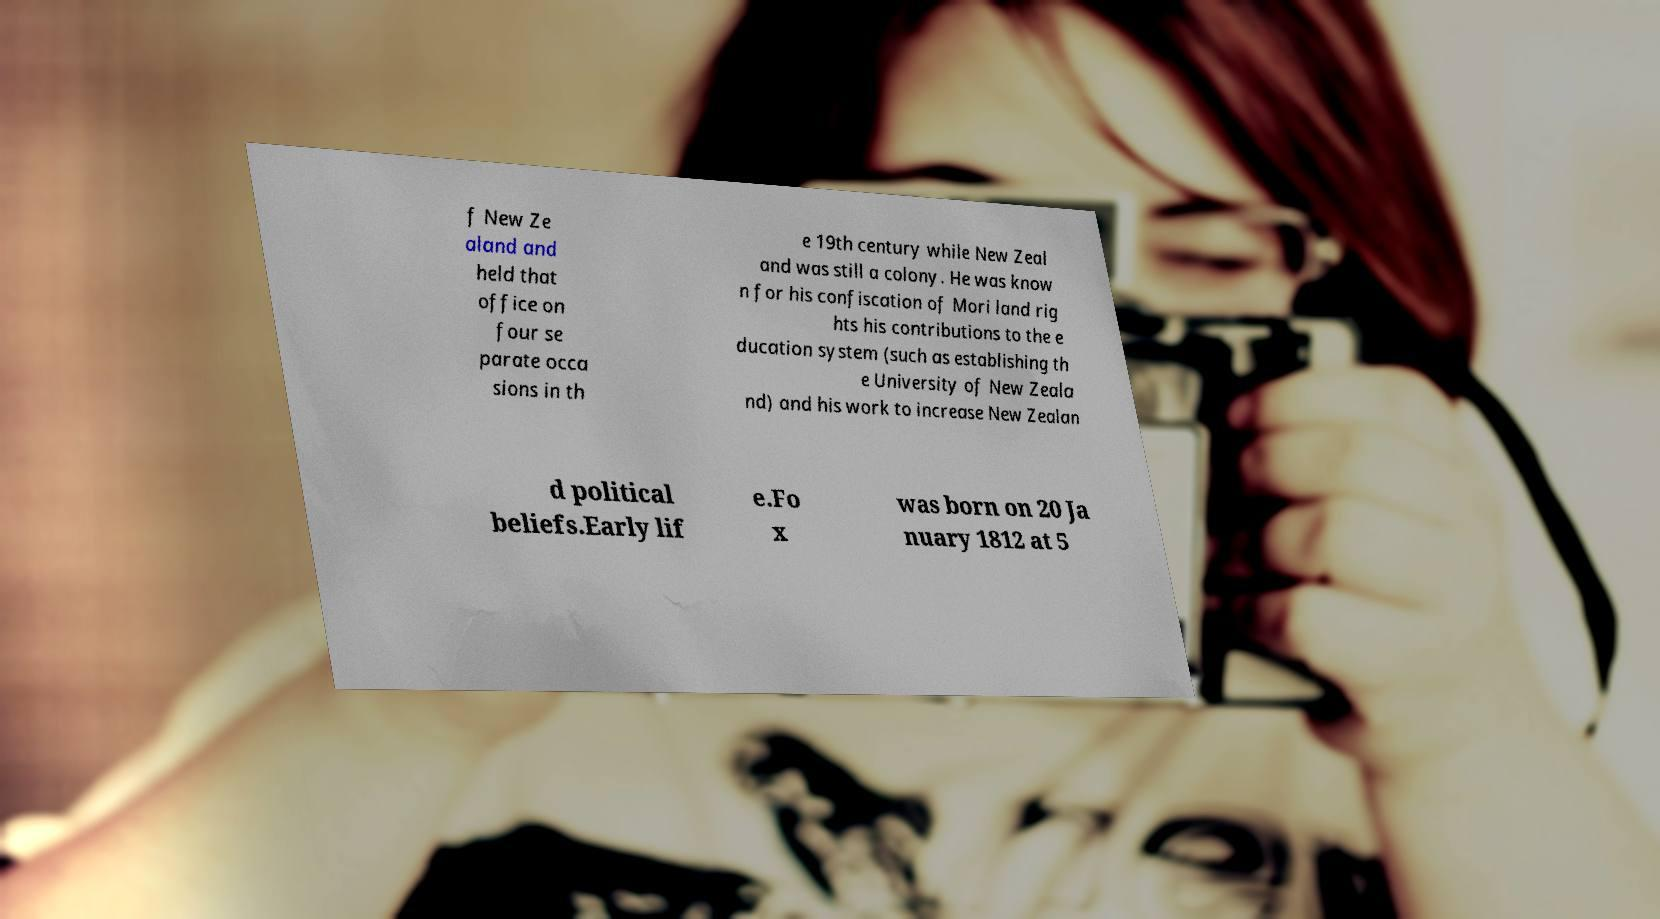Can you read and provide the text displayed in the image?This photo seems to have some interesting text. Can you extract and type it out for me? f New Ze aland and held that office on four se parate occa sions in th e 19th century while New Zeal and was still a colony. He was know n for his confiscation of Mori land rig hts his contributions to the e ducation system (such as establishing th e University of New Zeala nd) and his work to increase New Zealan d political beliefs.Early lif e.Fo x was born on 20 Ja nuary 1812 at 5 